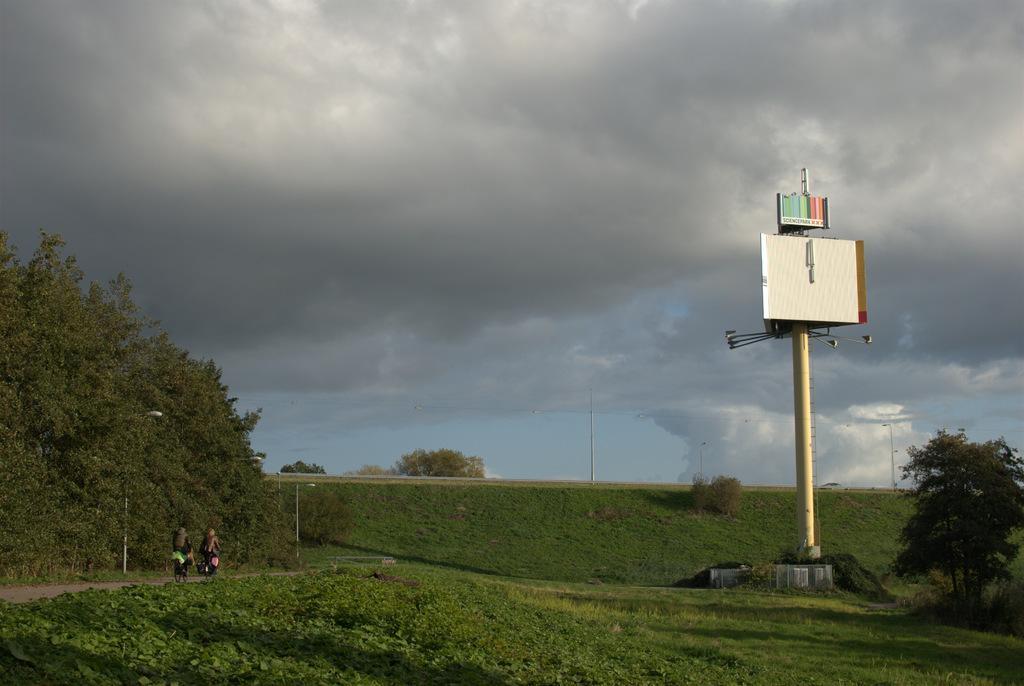Can you describe this image briefly? In this image I see the grass and I see 2 persons on the cycles and I see the path and I see the light poles and I see a pole over here on which there are boards and I see number of trees. In the background I see the cloudy sky. 